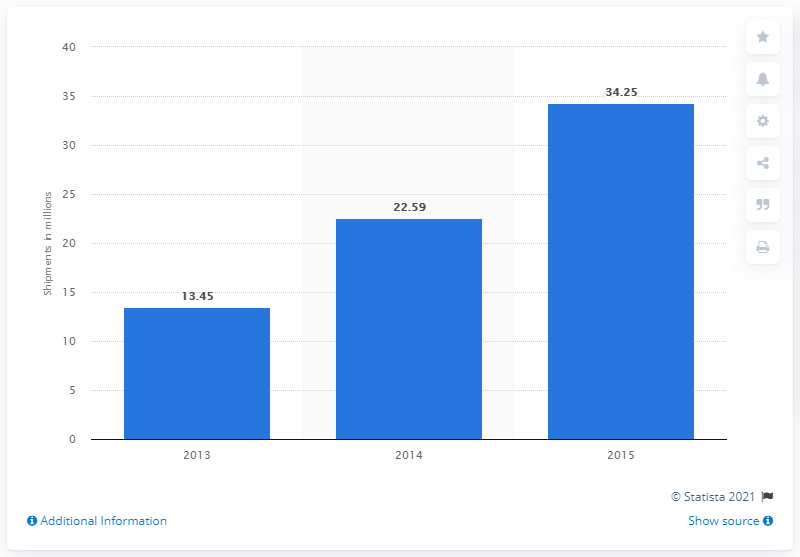Give some essential details in this illustration. It is estimated that 34.25 healthcare wearables will be shipped in 2015. 